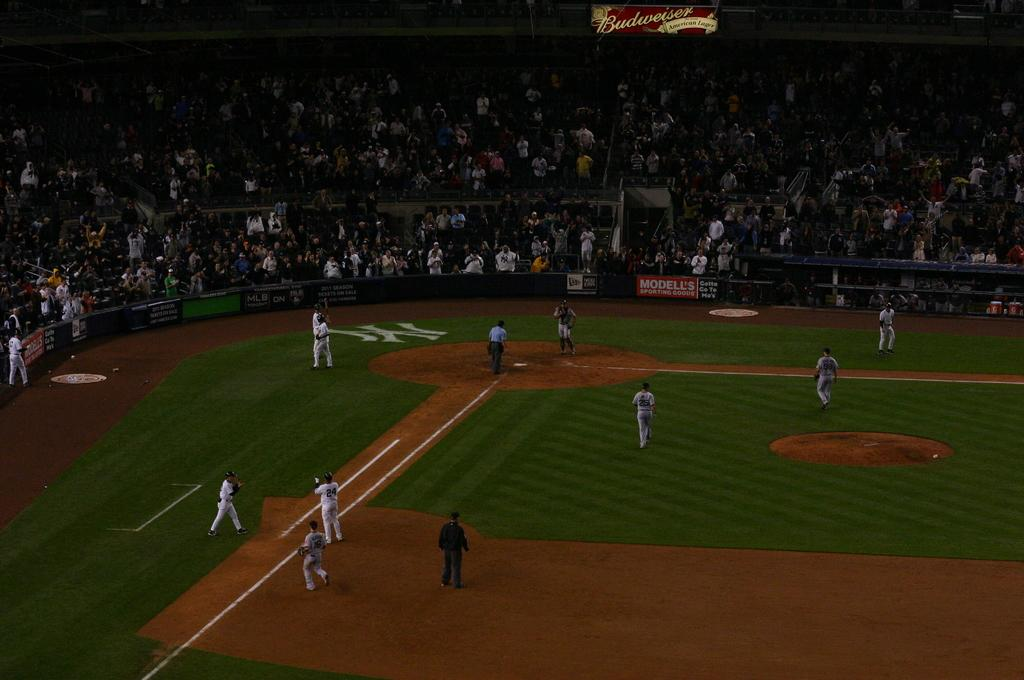<image>
Give a short and clear explanation of the subsequent image. Budweiser is sponsoring the baseball that is being played on the field. 